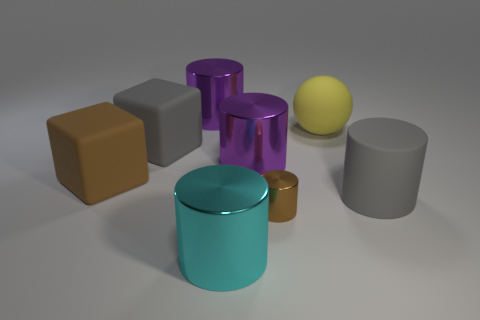What is the size of the gray matte object that is the same shape as the large cyan thing?
Provide a succinct answer. Large. Is there any other thing that is the same size as the gray rubber cylinder?
Provide a short and direct response. Yes. What number of objects are brown objects that are to the left of the large gray block or purple metallic cylinders that are on the right side of the large cyan cylinder?
Give a very brief answer. 2. Do the yellow matte object and the gray cylinder have the same size?
Offer a terse response. Yes. Are there more purple cylinders than small yellow shiny things?
Your response must be concise. Yes. How many other objects are there of the same color as the large matte ball?
Provide a short and direct response. 0. How many things are large cyan objects or gray rubber cubes?
Your answer should be very brief. 2. Is the shape of the large gray matte thing on the left side of the small brown metal thing the same as  the brown metallic thing?
Your response must be concise. No. The cube that is behind the large purple object to the right of the cyan metal cylinder is what color?
Make the answer very short. Gray. Are there fewer large blocks than big shiny things?
Your response must be concise. Yes. 